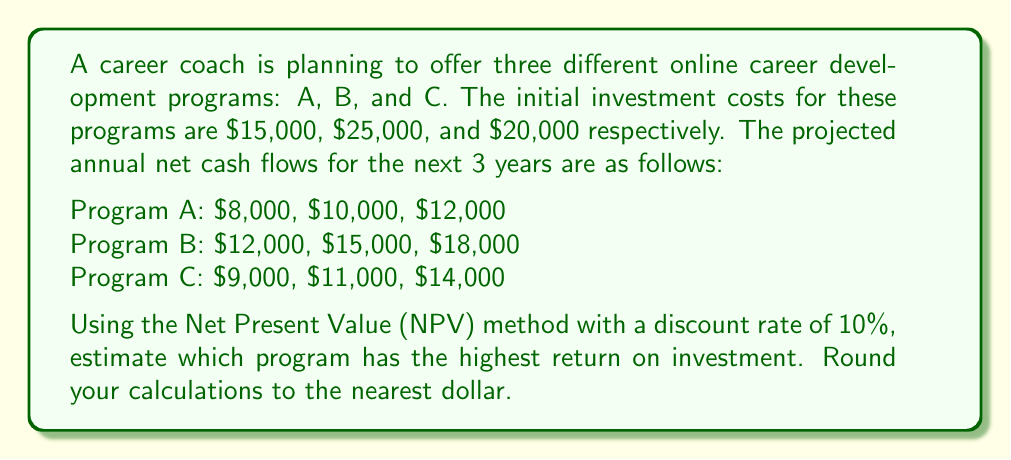What is the answer to this math problem? To determine which program has the highest return on investment, we'll calculate the Net Present Value (NPV) for each program using the given discount rate of 10%.

The NPV formula is:

$$ NPV = -C_0 + \sum_{t=1}^n \frac{C_t}{(1+r)^t} $$

Where:
$C_0$ = Initial investment
$C_t$ = Cash flow at time t
$r$ = Discount rate
$n$ = Number of periods

For each program:

1. Program A:
$$ NPV_A = -15000 + \frac{8000}{1.1} + \frac{10000}{1.1^2} + \frac{12000}{1.1^3} $$
$$ NPV_A = -15000 + 7273 + 8264 + 9008 = \$9,545 $$

2. Program B:
$$ NPV_B = -25000 + \frac{12000}{1.1} + \frac{15000}{1.1^2} + \frac{18000}{1.1^3} $$
$$ NPV_B = -25000 + 10909 + 12397 + 13512 = \$11,818 $$

3. Program C:
$$ NPV_C = -20000 + \frac{9000}{1.1} + \frac{11000}{1.1^2} + \frac{14000}{1.1^3} $$
$$ NPV_C = -20000 + 8182 + 9091 + 10510 = \$7,783 $$

To calculate the Return on Investment (ROI), we'll use the formula:

$$ ROI = \frac{NPV}{Initial Investment} \times 100\% $$

Program A ROI: $\frac{9545}{15000} \times 100\% = 63.63\%$
Program B ROI: $\frac{11818}{25000} \times 100\% = 47.27\%$
Program C ROI: $\frac{7783}{20000} \times 100\% = 38.92\%$
Answer: Program A (63.63% ROI) 